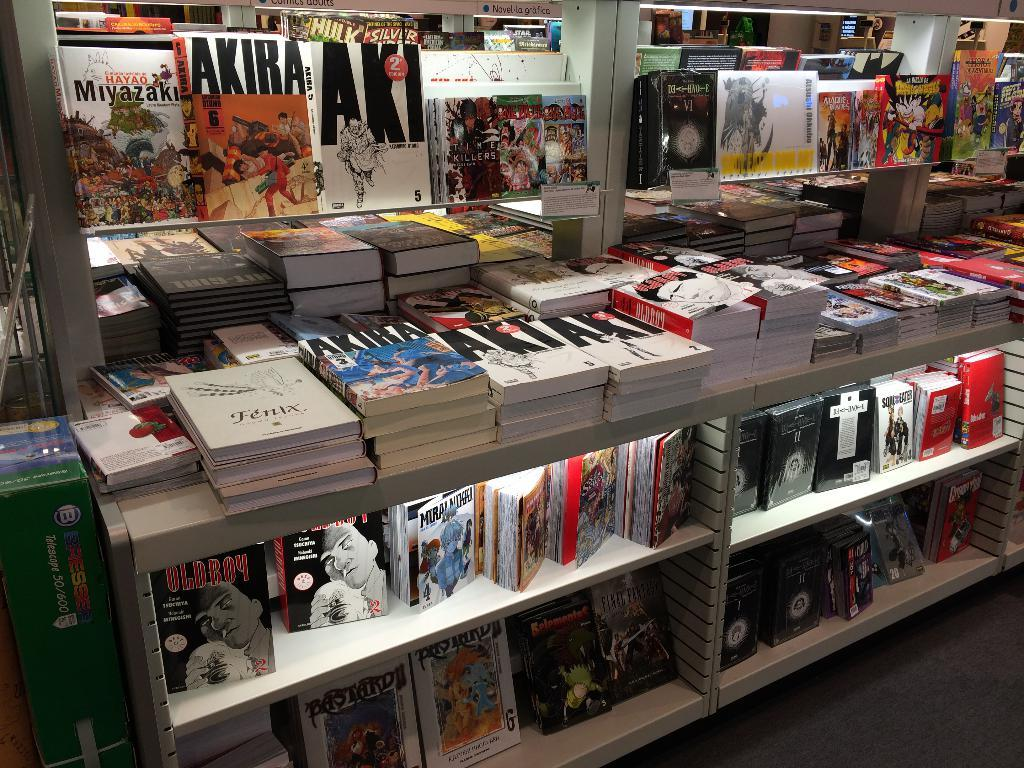Provide a one-sentence caption for the provided image. A display of a bunch of books with one titles AKIRA. 